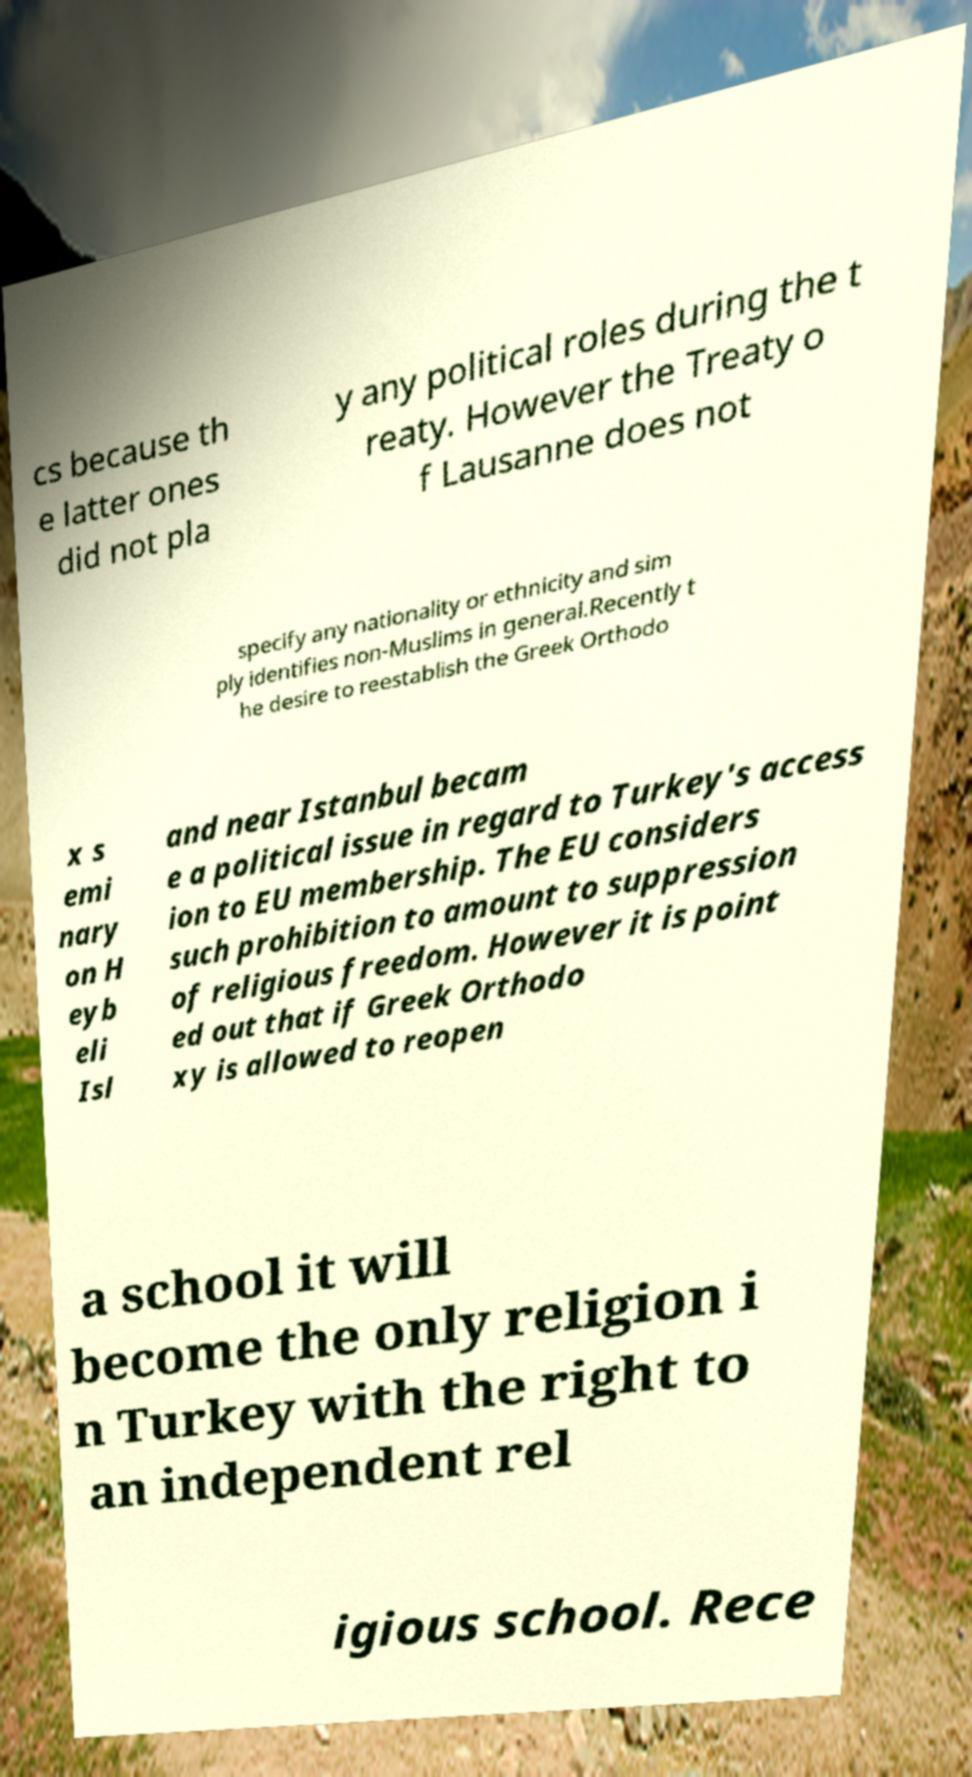Can you accurately transcribe the text from the provided image for me? cs because th e latter ones did not pla y any political roles during the t reaty. However the Treaty o f Lausanne does not specify any nationality or ethnicity and sim ply identifies non-Muslims in general.Recently t he desire to reestablish the Greek Orthodo x s emi nary on H eyb eli Isl and near Istanbul becam e a political issue in regard to Turkey's access ion to EU membership. The EU considers such prohibition to amount to suppression of religious freedom. However it is point ed out that if Greek Orthodo xy is allowed to reopen a school it will become the only religion i n Turkey with the right to an independent rel igious school. Rece 